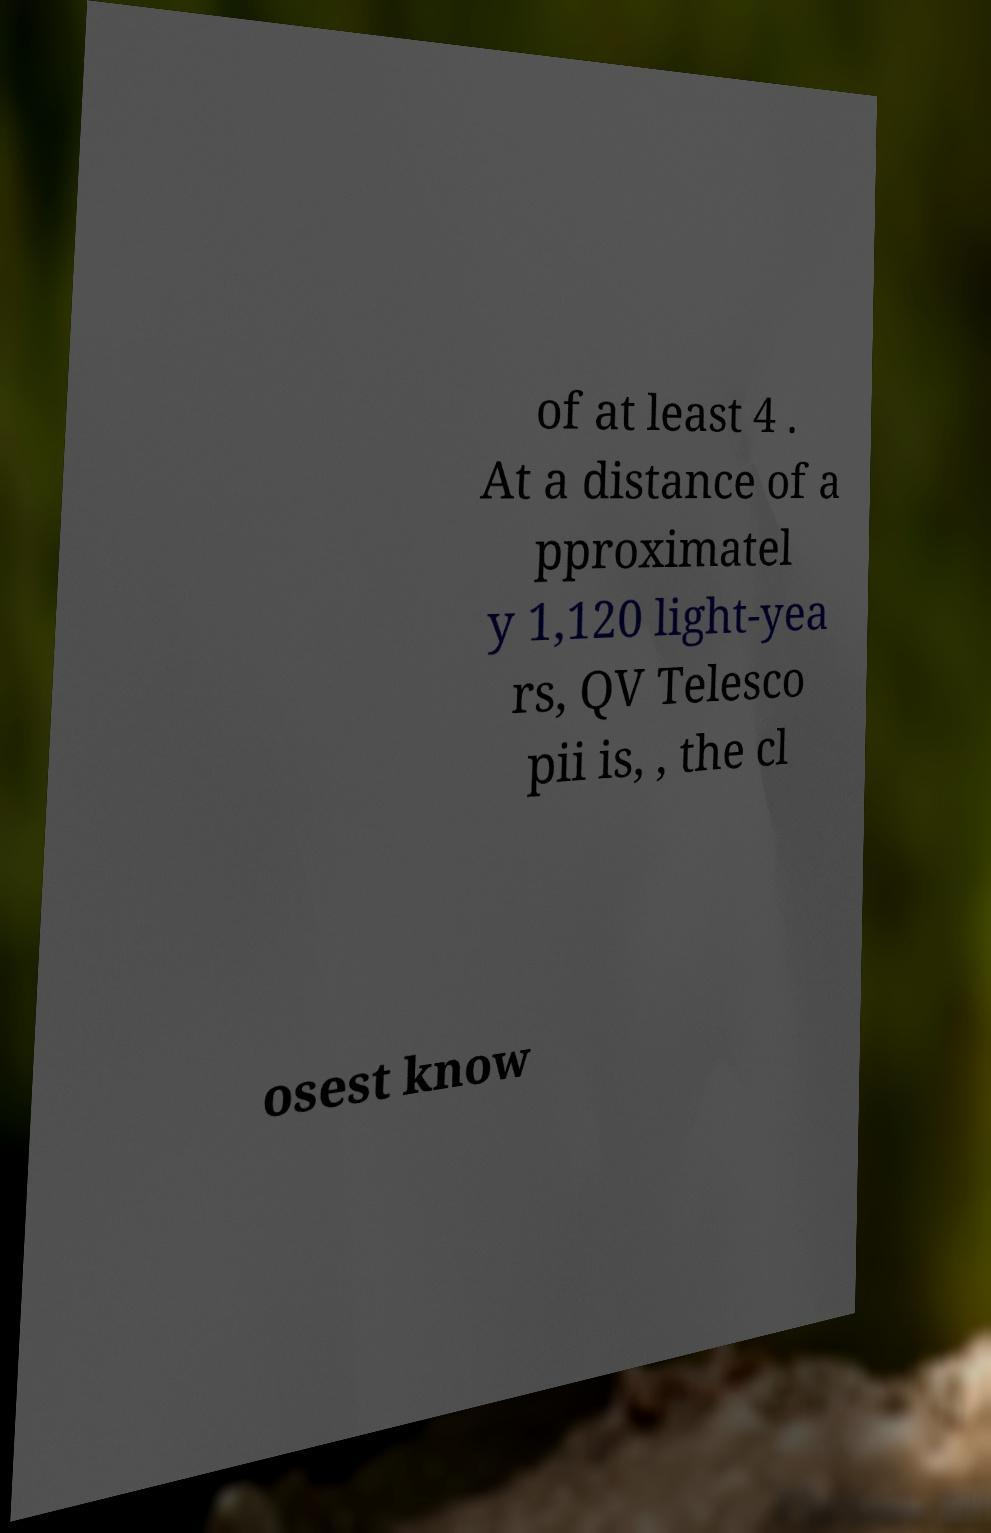I need the written content from this picture converted into text. Can you do that? of at least 4 . At a distance of a pproximatel y 1,120 light-yea rs, QV Telesco pii is, , the cl osest know 